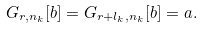<formula> <loc_0><loc_0><loc_500><loc_500>G _ { r , n _ { k } } [ b ] = G _ { r + l _ { k } , n _ { k } } [ b ] = a .</formula> 